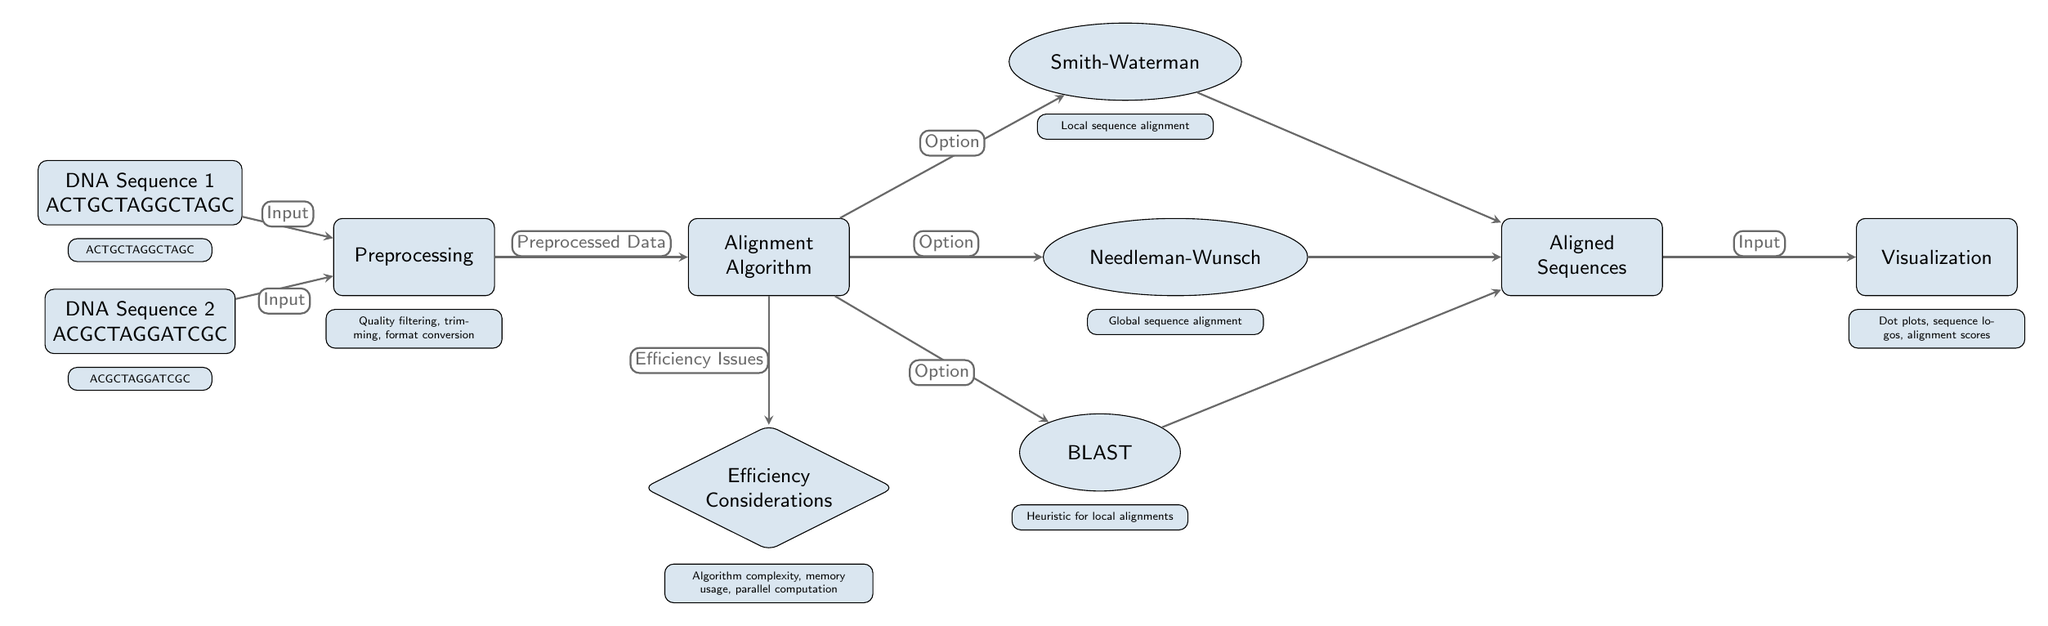What are the two DNA sequences used as input? The inputs are specifically labeled at the start of the diagram in the data nodes. The sequences are "ACTGCTAGGCTAGC" and "ACGCTAGGATCGC."
Answer: ACTGCTAGGCTAGC, ACGCTAGGATCGC What is the role of the preprocessing node? The preprocessing node is described below as involving quality filtering, trimming, and format conversion, indicating its purpose in preparing the sequences for alignment.
Answer: Quality filtering, trimming, format conversion How many alignment algorithms are listed in the diagram? There are three algorithms indicated in the diagram: Smith-Waterman, Needleman-Wunsch, and BLAST. The flow from the alignment node branches to three different algorithms.
Answer: 3 Which algorithm is associated with local sequence alignment? The diagram specifies that the Smith-Waterman algorithm is used for local sequence alignment, as indicated in the information below its node.
Answer: Smith-Waterman What are the considerations mentioned regarding efficiency in sequence alignment? The efficiency considerations node states that algorithm complexity, memory usage, and parallel computation are all factors to consider, providing insight into the performance of alignment methods.
Answer: Algorithm complexity, memory usage, parallel computation What do the aligned sequences connect to in the diagram? The aligned sequences node connects to the visualization node, indicating that the output of the alignment process is used for visual representations.
Answer: Visualization Which alignment option is considered a heuristic? The BLAST algorithm is designated in the diagram as a heuristic for local alignments, which is indicated under its respective node.
Answer: BLAST How does the alignment node connect to the efficiency considerations? The diagram illustrates that the alignment node leads to the efficiency considerations node, labeled as efficiency issues, indicating a dependency on the alignment process's efficiency metrics.
Answer: Efficiency Issues 